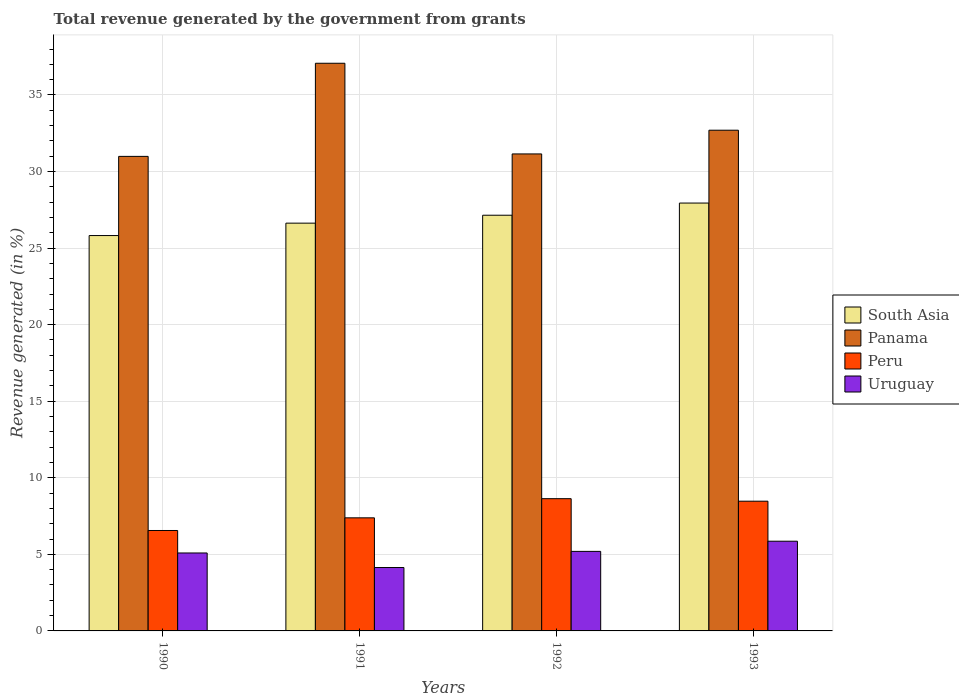How many different coloured bars are there?
Provide a short and direct response. 4. Are the number of bars per tick equal to the number of legend labels?
Your answer should be very brief. Yes. Are the number of bars on each tick of the X-axis equal?
Your response must be concise. Yes. How many bars are there on the 1st tick from the left?
Offer a terse response. 4. How many bars are there on the 3rd tick from the right?
Provide a succinct answer. 4. What is the total revenue generated in Panama in 1990?
Offer a terse response. 30.99. Across all years, what is the maximum total revenue generated in South Asia?
Provide a succinct answer. 27.94. Across all years, what is the minimum total revenue generated in Panama?
Ensure brevity in your answer.  30.99. In which year was the total revenue generated in Peru minimum?
Keep it short and to the point. 1990. What is the total total revenue generated in South Asia in the graph?
Give a very brief answer. 107.54. What is the difference between the total revenue generated in Panama in 1991 and that in 1992?
Provide a succinct answer. 5.92. What is the difference between the total revenue generated in Uruguay in 1991 and the total revenue generated in Panama in 1990?
Give a very brief answer. -26.85. What is the average total revenue generated in South Asia per year?
Your answer should be compact. 26.88. In the year 1993, what is the difference between the total revenue generated in Peru and total revenue generated in Panama?
Your response must be concise. -24.23. What is the ratio of the total revenue generated in Panama in 1990 to that in 1992?
Give a very brief answer. 0.99. Is the total revenue generated in Peru in 1991 less than that in 1992?
Keep it short and to the point. Yes. Is the difference between the total revenue generated in Peru in 1992 and 1993 greater than the difference between the total revenue generated in Panama in 1992 and 1993?
Make the answer very short. Yes. What is the difference between the highest and the second highest total revenue generated in Peru?
Provide a short and direct response. 0.16. What is the difference between the highest and the lowest total revenue generated in Peru?
Your response must be concise. 2.08. In how many years, is the total revenue generated in Peru greater than the average total revenue generated in Peru taken over all years?
Keep it short and to the point. 2. Is it the case that in every year, the sum of the total revenue generated in Uruguay and total revenue generated in South Asia is greater than the sum of total revenue generated in Panama and total revenue generated in Peru?
Ensure brevity in your answer.  No. What does the 4th bar from the left in 1990 represents?
Your answer should be compact. Uruguay. What does the 1st bar from the right in 1993 represents?
Your answer should be compact. Uruguay. How many bars are there?
Ensure brevity in your answer.  16. How many years are there in the graph?
Provide a succinct answer. 4. What is the difference between two consecutive major ticks on the Y-axis?
Offer a very short reply. 5. Does the graph contain grids?
Offer a terse response. Yes. How are the legend labels stacked?
Offer a terse response. Vertical. What is the title of the graph?
Keep it short and to the point. Total revenue generated by the government from grants. What is the label or title of the X-axis?
Make the answer very short. Years. What is the label or title of the Y-axis?
Offer a very short reply. Revenue generated (in %). What is the Revenue generated (in %) in South Asia in 1990?
Provide a succinct answer. 25.82. What is the Revenue generated (in %) in Panama in 1990?
Ensure brevity in your answer.  30.99. What is the Revenue generated (in %) in Peru in 1990?
Give a very brief answer. 6.56. What is the Revenue generated (in %) in Uruguay in 1990?
Ensure brevity in your answer.  5.09. What is the Revenue generated (in %) in South Asia in 1991?
Ensure brevity in your answer.  26.63. What is the Revenue generated (in %) in Panama in 1991?
Keep it short and to the point. 37.07. What is the Revenue generated (in %) in Peru in 1991?
Keep it short and to the point. 7.38. What is the Revenue generated (in %) in Uruguay in 1991?
Give a very brief answer. 4.14. What is the Revenue generated (in %) in South Asia in 1992?
Give a very brief answer. 27.15. What is the Revenue generated (in %) of Panama in 1992?
Make the answer very short. 31.15. What is the Revenue generated (in %) in Peru in 1992?
Offer a terse response. 8.64. What is the Revenue generated (in %) in Uruguay in 1992?
Offer a terse response. 5.19. What is the Revenue generated (in %) of South Asia in 1993?
Give a very brief answer. 27.94. What is the Revenue generated (in %) in Panama in 1993?
Your answer should be compact. 32.7. What is the Revenue generated (in %) of Peru in 1993?
Keep it short and to the point. 8.47. What is the Revenue generated (in %) of Uruguay in 1993?
Offer a very short reply. 5.86. Across all years, what is the maximum Revenue generated (in %) in South Asia?
Provide a short and direct response. 27.94. Across all years, what is the maximum Revenue generated (in %) in Panama?
Make the answer very short. 37.07. Across all years, what is the maximum Revenue generated (in %) in Peru?
Make the answer very short. 8.64. Across all years, what is the maximum Revenue generated (in %) of Uruguay?
Your answer should be very brief. 5.86. Across all years, what is the minimum Revenue generated (in %) in South Asia?
Ensure brevity in your answer.  25.82. Across all years, what is the minimum Revenue generated (in %) in Panama?
Your answer should be very brief. 30.99. Across all years, what is the minimum Revenue generated (in %) in Peru?
Provide a short and direct response. 6.56. Across all years, what is the minimum Revenue generated (in %) in Uruguay?
Provide a succinct answer. 4.14. What is the total Revenue generated (in %) of South Asia in the graph?
Your answer should be very brief. 107.54. What is the total Revenue generated (in %) in Panama in the graph?
Offer a terse response. 131.91. What is the total Revenue generated (in %) of Peru in the graph?
Keep it short and to the point. 31.05. What is the total Revenue generated (in %) in Uruguay in the graph?
Your answer should be very brief. 20.28. What is the difference between the Revenue generated (in %) of South Asia in 1990 and that in 1991?
Your answer should be very brief. -0.81. What is the difference between the Revenue generated (in %) of Panama in 1990 and that in 1991?
Make the answer very short. -6.08. What is the difference between the Revenue generated (in %) of Peru in 1990 and that in 1991?
Your response must be concise. -0.83. What is the difference between the Revenue generated (in %) in Uruguay in 1990 and that in 1991?
Provide a short and direct response. 0.95. What is the difference between the Revenue generated (in %) in South Asia in 1990 and that in 1992?
Keep it short and to the point. -1.33. What is the difference between the Revenue generated (in %) of Panama in 1990 and that in 1992?
Your response must be concise. -0.16. What is the difference between the Revenue generated (in %) in Peru in 1990 and that in 1992?
Offer a very short reply. -2.08. What is the difference between the Revenue generated (in %) of Uruguay in 1990 and that in 1992?
Provide a succinct answer. -0.1. What is the difference between the Revenue generated (in %) in South Asia in 1990 and that in 1993?
Provide a short and direct response. -2.12. What is the difference between the Revenue generated (in %) in Panama in 1990 and that in 1993?
Offer a very short reply. -1.71. What is the difference between the Revenue generated (in %) in Peru in 1990 and that in 1993?
Offer a very short reply. -1.91. What is the difference between the Revenue generated (in %) in Uruguay in 1990 and that in 1993?
Keep it short and to the point. -0.77. What is the difference between the Revenue generated (in %) of South Asia in 1991 and that in 1992?
Make the answer very short. -0.52. What is the difference between the Revenue generated (in %) in Panama in 1991 and that in 1992?
Offer a terse response. 5.92. What is the difference between the Revenue generated (in %) of Peru in 1991 and that in 1992?
Ensure brevity in your answer.  -1.25. What is the difference between the Revenue generated (in %) of Uruguay in 1991 and that in 1992?
Ensure brevity in your answer.  -1.05. What is the difference between the Revenue generated (in %) in South Asia in 1991 and that in 1993?
Provide a succinct answer. -1.31. What is the difference between the Revenue generated (in %) of Panama in 1991 and that in 1993?
Offer a very short reply. 4.37. What is the difference between the Revenue generated (in %) of Peru in 1991 and that in 1993?
Your answer should be compact. -1.09. What is the difference between the Revenue generated (in %) of Uruguay in 1991 and that in 1993?
Give a very brief answer. -1.72. What is the difference between the Revenue generated (in %) in South Asia in 1992 and that in 1993?
Provide a short and direct response. -0.8. What is the difference between the Revenue generated (in %) of Panama in 1992 and that in 1993?
Your answer should be very brief. -1.55. What is the difference between the Revenue generated (in %) in Peru in 1992 and that in 1993?
Provide a succinct answer. 0.16. What is the difference between the Revenue generated (in %) of Uruguay in 1992 and that in 1993?
Your answer should be compact. -0.66. What is the difference between the Revenue generated (in %) of South Asia in 1990 and the Revenue generated (in %) of Panama in 1991?
Offer a terse response. -11.25. What is the difference between the Revenue generated (in %) of South Asia in 1990 and the Revenue generated (in %) of Peru in 1991?
Ensure brevity in your answer.  18.43. What is the difference between the Revenue generated (in %) of South Asia in 1990 and the Revenue generated (in %) of Uruguay in 1991?
Ensure brevity in your answer.  21.68. What is the difference between the Revenue generated (in %) in Panama in 1990 and the Revenue generated (in %) in Peru in 1991?
Your response must be concise. 23.61. What is the difference between the Revenue generated (in %) in Panama in 1990 and the Revenue generated (in %) in Uruguay in 1991?
Offer a very short reply. 26.85. What is the difference between the Revenue generated (in %) in Peru in 1990 and the Revenue generated (in %) in Uruguay in 1991?
Offer a very short reply. 2.42. What is the difference between the Revenue generated (in %) of South Asia in 1990 and the Revenue generated (in %) of Panama in 1992?
Keep it short and to the point. -5.33. What is the difference between the Revenue generated (in %) of South Asia in 1990 and the Revenue generated (in %) of Peru in 1992?
Provide a succinct answer. 17.18. What is the difference between the Revenue generated (in %) in South Asia in 1990 and the Revenue generated (in %) in Uruguay in 1992?
Give a very brief answer. 20.62. What is the difference between the Revenue generated (in %) in Panama in 1990 and the Revenue generated (in %) in Peru in 1992?
Your answer should be very brief. 22.35. What is the difference between the Revenue generated (in %) of Panama in 1990 and the Revenue generated (in %) of Uruguay in 1992?
Offer a terse response. 25.8. What is the difference between the Revenue generated (in %) of Peru in 1990 and the Revenue generated (in %) of Uruguay in 1992?
Provide a succinct answer. 1.36. What is the difference between the Revenue generated (in %) of South Asia in 1990 and the Revenue generated (in %) of Panama in 1993?
Offer a terse response. -6.88. What is the difference between the Revenue generated (in %) in South Asia in 1990 and the Revenue generated (in %) in Peru in 1993?
Your response must be concise. 17.35. What is the difference between the Revenue generated (in %) in South Asia in 1990 and the Revenue generated (in %) in Uruguay in 1993?
Ensure brevity in your answer.  19.96. What is the difference between the Revenue generated (in %) in Panama in 1990 and the Revenue generated (in %) in Peru in 1993?
Offer a very short reply. 22.52. What is the difference between the Revenue generated (in %) in Panama in 1990 and the Revenue generated (in %) in Uruguay in 1993?
Keep it short and to the point. 25.13. What is the difference between the Revenue generated (in %) of Peru in 1990 and the Revenue generated (in %) of Uruguay in 1993?
Provide a short and direct response. 0.7. What is the difference between the Revenue generated (in %) in South Asia in 1991 and the Revenue generated (in %) in Panama in 1992?
Provide a succinct answer. -4.52. What is the difference between the Revenue generated (in %) of South Asia in 1991 and the Revenue generated (in %) of Peru in 1992?
Ensure brevity in your answer.  17.99. What is the difference between the Revenue generated (in %) in South Asia in 1991 and the Revenue generated (in %) in Uruguay in 1992?
Ensure brevity in your answer.  21.44. What is the difference between the Revenue generated (in %) of Panama in 1991 and the Revenue generated (in %) of Peru in 1992?
Your response must be concise. 28.44. What is the difference between the Revenue generated (in %) of Panama in 1991 and the Revenue generated (in %) of Uruguay in 1992?
Your response must be concise. 31.88. What is the difference between the Revenue generated (in %) of Peru in 1991 and the Revenue generated (in %) of Uruguay in 1992?
Offer a very short reply. 2.19. What is the difference between the Revenue generated (in %) of South Asia in 1991 and the Revenue generated (in %) of Panama in 1993?
Your answer should be very brief. -6.07. What is the difference between the Revenue generated (in %) of South Asia in 1991 and the Revenue generated (in %) of Peru in 1993?
Offer a terse response. 18.16. What is the difference between the Revenue generated (in %) of South Asia in 1991 and the Revenue generated (in %) of Uruguay in 1993?
Ensure brevity in your answer.  20.77. What is the difference between the Revenue generated (in %) of Panama in 1991 and the Revenue generated (in %) of Peru in 1993?
Offer a very short reply. 28.6. What is the difference between the Revenue generated (in %) in Panama in 1991 and the Revenue generated (in %) in Uruguay in 1993?
Your response must be concise. 31.21. What is the difference between the Revenue generated (in %) of Peru in 1991 and the Revenue generated (in %) of Uruguay in 1993?
Give a very brief answer. 1.53. What is the difference between the Revenue generated (in %) of South Asia in 1992 and the Revenue generated (in %) of Panama in 1993?
Provide a succinct answer. -5.55. What is the difference between the Revenue generated (in %) in South Asia in 1992 and the Revenue generated (in %) in Peru in 1993?
Provide a short and direct response. 18.68. What is the difference between the Revenue generated (in %) of South Asia in 1992 and the Revenue generated (in %) of Uruguay in 1993?
Make the answer very short. 21.29. What is the difference between the Revenue generated (in %) in Panama in 1992 and the Revenue generated (in %) in Peru in 1993?
Ensure brevity in your answer.  22.68. What is the difference between the Revenue generated (in %) in Panama in 1992 and the Revenue generated (in %) in Uruguay in 1993?
Provide a short and direct response. 25.29. What is the difference between the Revenue generated (in %) in Peru in 1992 and the Revenue generated (in %) in Uruguay in 1993?
Your answer should be compact. 2.78. What is the average Revenue generated (in %) in South Asia per year?
Make the answer very short. 26.88. What is the average Revenue generated (in %) of Panama per year?
Your answer should be very brief. 32.98. What is the average Revenue generated (in %) in Peru per year?
Keep it short and to the point. 7.76. What is the average Revenue generated (in %) of Uruguay per year?
Provide a short and direct response. 5.07. In the year 1990, what is the difference between the Revenue generated (in %) in South Asia and Revenue generated (in %) in Panama?
Make the answer very short. -5.17. In the year 1990, what is the difference between the Revenue generated (in %) in South Asia and Revenue generated (in %) in Peru?
Keep it short and to the point. 19.26. In the year 1990, what is the difference between the Revenue generated (in %) in South Asia and Revenue generated (in %) in Uruguay?
Provide a succinct answer. 20.73. In the year 1990, what is the difference between the Revenue generated (in %) in Panama and Revenue generated (in %) in Peru?
Ensure brevity in your answer.  24.43. In the year 1990, what is the difference between the Revenue generated (in %) in Panama and Revenue generated (in %) in Uruguay?
Offer a terse response. 25.9. In the year 1990, what is the difference between the Revenue generated (in %) in Peru and Revenue generated (in %) in Uruguay?
Your answer should be very brief. 1.47. In the year 1991, what is the difference between the Revenue generated (in %) of South Asia and Revenue generated (in %) of Panama?
Keep it short and to the point. -10.44. In the year 1991, what is the difference between the Revenue generated (in %) in South Asia and Revenue generated (in %) in Peru?
Provide a succinct answer. 19.24. In the year 1991, what is the difference between the Revenue generated (in %) of South Asia and Revenue generated (in %) of Uruguay?
Make the answer very short. 22.49. In the year 1991, what is the difference between the Revenue generated (in %) of Panama and Revenue generated (in %) of Peru?
Ensure brevity in your answer.  29.69. In the year 1991, what is the difference between the Revenue generated (in %) of Panama and Revenue generated (in %) of Uruguay?
Provide a short and direct response. 32.93. In the year 1991, what is the difference between the Revenue generated (in %) of Peru and Revenue generated (in %) of Uruguay?
Offer a terse response. 3.24. In the year 1992, what is the difference between the Revenue generated (in %) in South Asia and Revenue generated (in %) in Panama?
Your response must be concise. -4. In the year 1992, what is the difference between the Revenue generated (in %) of South Asia and Revenue generated (in %) of Peru?
Offer a very short reply. 18.51. In the year 1992, what is the difference between the Revenue generated (in %) in South Asia and Revenue generated (in %) in Uruguay?
Offer a terse response. 21.95. In the year 1992, what is the difference between the Revenue generated (in %) in Panama and Revenue generated (in %) in Peru?
Provide a short and direct response. 22.51. In the year 1992, what is the difference between the Revenue generated (in %) of Panama and Revenue generated (in %) of Uruguay?
Provide a succinct answer. 25.96. In the year 1992, what is the difference between the Revenue generated (in %) in Peru and Revenue generated (in %) in Uruguay?
Your answer should be very brief. 3.44. In the year 1993, what is the difference between the Revenue generated (in %) in South Asia and Revenue generated (in %) in Panama?
Keep it short and to the point. -4.76. In the year 1993, what is the difference between the Revenue generated (in %) of South Asia and Revenue generated (in %) of Peru?
Provide a succinct answer. 19.47. In the year 1993, what is the difference between the Revenue generated (in %) in South Asia and Revenue generated (in %) in Uruguay?
Provide a short and direct response. 22.08. In the year 1993, what is the difference between the Revenue generated (in %) of Panama and Revenue generated (in %) of Peru?
Your answer should be very brief. 24.23. In the year 1993, what is the difference between the Revenue generated (in %) of Panama and Revenue generated (in %) of Uruguay?
Provide a short and direct response. 26.84. In the year 1993, what is the difference between the Revenue generated (in %) in Peru and Revenue generated (in %) in Uruguay?
Ensure brevity in your answer.  2.61. What is the ratio of the Revenue generated (in %) of South Asia in 1990 to that in 1991?
Provide a succinct answer. 0.97. What is the ratio of the Revenue generated (in %) of Panama in 1990 to that in 1991?
Keep it short and to the point. 0.84. What is the ratio of the Revenue generated (in %) in Peru in 1990 to that in 1991?
Make the answer very short. 0.89. What is the ratio of the Revenue generated (in %) of Uruguay in 1990 to that in 1991?
Provide a short and direct response. 1.23. What is the ratio of the Revenue generated (in %) in South Asia in 1990 to that in 1992?
Offer a terse response. 0.95. What is the ratio of the Revenue generated (in %) of Peru in 1990 to that in 1992?
Give a very brief answer. 0.76. What is the ratio of the Revenue generated (in %) in Uruguay in 1990 to that in 1992?
Your answer should be compact. 0.98. What is the ratio of the Revenue generated (in %) in South Asia in 1990 to that in 1993?
Offer a terse response. 0.92. What is the ratio of the Revenue generated (in %) in Panama in 1990 to that in 1993?
Give a very brief answer. 0.95. What is the ratio of the Revenue generated (in %) in Peru in 1990 to that in 1993?
Keep it short and to the point. 0.77. What is the ratio of the Revenue generated (in %) in Uruguay in 1990 to that in 1993?
Provide a succinct answer. 0.87. What is the ratio of the Revenue generated (in %) in South Asia in 1991 to that in 1992?
Provide a succinct answer. 0.98. What is the ratio of the Revenue generated (in %) of Panama in 1991 to that in 1992?
Make the answer very short. 1.19. What is the ratio of the Revenue generated (in %) in Peru in 1991 to that in 1992?
Offer a very short reply. 0.86. What is the ratio of the Revenue generated (in %) in Uruguay in 1991 to that in 1992?
Offer a terse response. 0.8. What is the ratio of the Revenue generated (in %) in South Asia in 1991 to that in 1993?
Your answer should be very brief. 0.95. What is the ratio of the Revenue generated (in %) of Panama in 1991 to that in 1993?
Your answer should be very brief. 1.13. What is the ratio of the Revenue generated (in %) of Peru in 1991 to that in 1993?
Your answer should be compact. 0.87. What is the ratio of the Revenue generated (in %) in Uruguay in 1991 to that in 1993?
Offer a terse response. 0.71. What is the ratio of the Revenue generated (in %) of South Asia in 1992 to that in 1993?
Offer a very short reply. 0.97. What is the ratio of the Revenue generated (in %) of Panama in 1992 to that in 1993?
Make the answer very short. 0.95. What is the ratio of the Revenue generated (in %) of Peru in 1992 to that in 1993?
Provide a short and direct response. 1.02. What is the ratio of the Revenue generated (in %) of Uruguay in 1992 to that in 1993?
Make the answer very short. 0.89. What is the difference between the highest and the second highest Revenue generated (in %) of South Asia?
Offer a very short reply. 0.8. What is the difference between the highest and the second highest Revenue generated (in %) of Panama?
Ensure brevity in your answer.  4.37. What is the difference between the highest and the second highest Revenue generated (in %) in Peru?
Make the answer very short. 0.16. What is the difference between the highest and the second highest Revenue generated (in %) of Uruguay?
Offer a terse response. 0.66. What is the difference between the highest and the lowest Revenue generated (in %) of South Asia?
Offer a very short reply. 2.12. What is the difference between the highest and the lowest Revenue generated (in %) in Panama?
Offer a very short reply. 6.08. What is the difference between the highest and the lowest Revenue generated (in %) of Peru?
Make the answer very short. 2.08. What is the difference between the highest and the lowest Revenue generated (in %) in Uruguay?
Offer a very short reply. 1.72. 